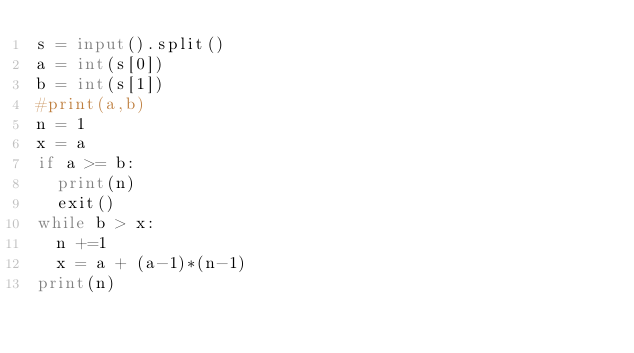<code> <loc_0><loc_0><loc_500><loc_500><_Python_>s = input().split()
a = int(s[0])
b = int(s[1])
#print(a,b)
n = 1
x = a
if a >= b:
  print(n)
  exit()
while b > x:
  n +=1
  x = a + (a-1)*(n-1)
print(n)  </code> 